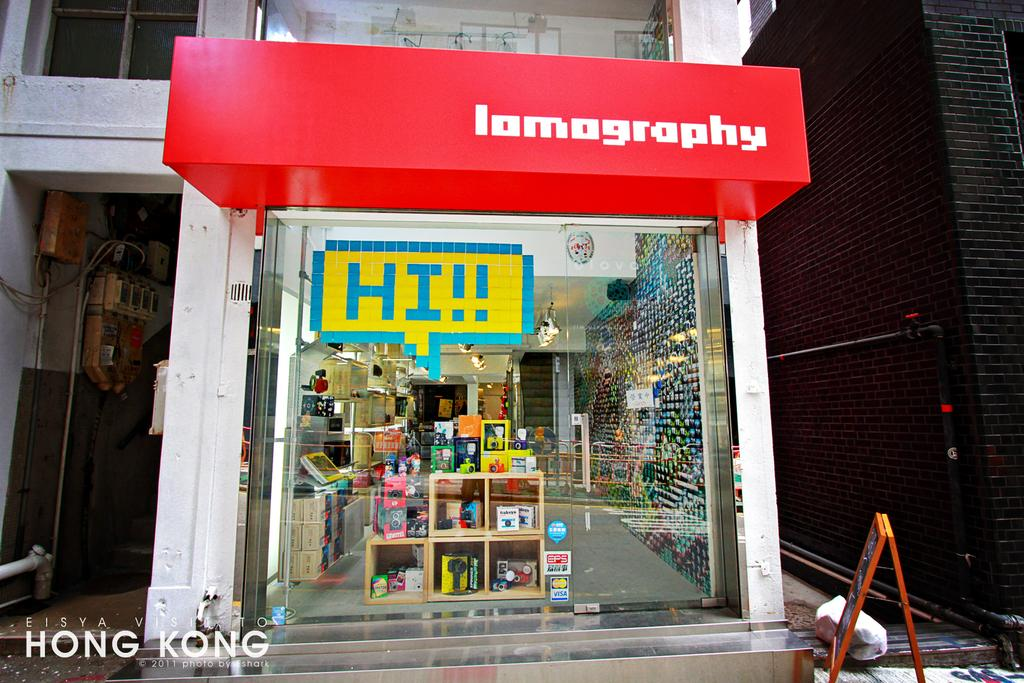<image>
Provide a brief description of the given image. An open store that is called Lomography and a glass door. 